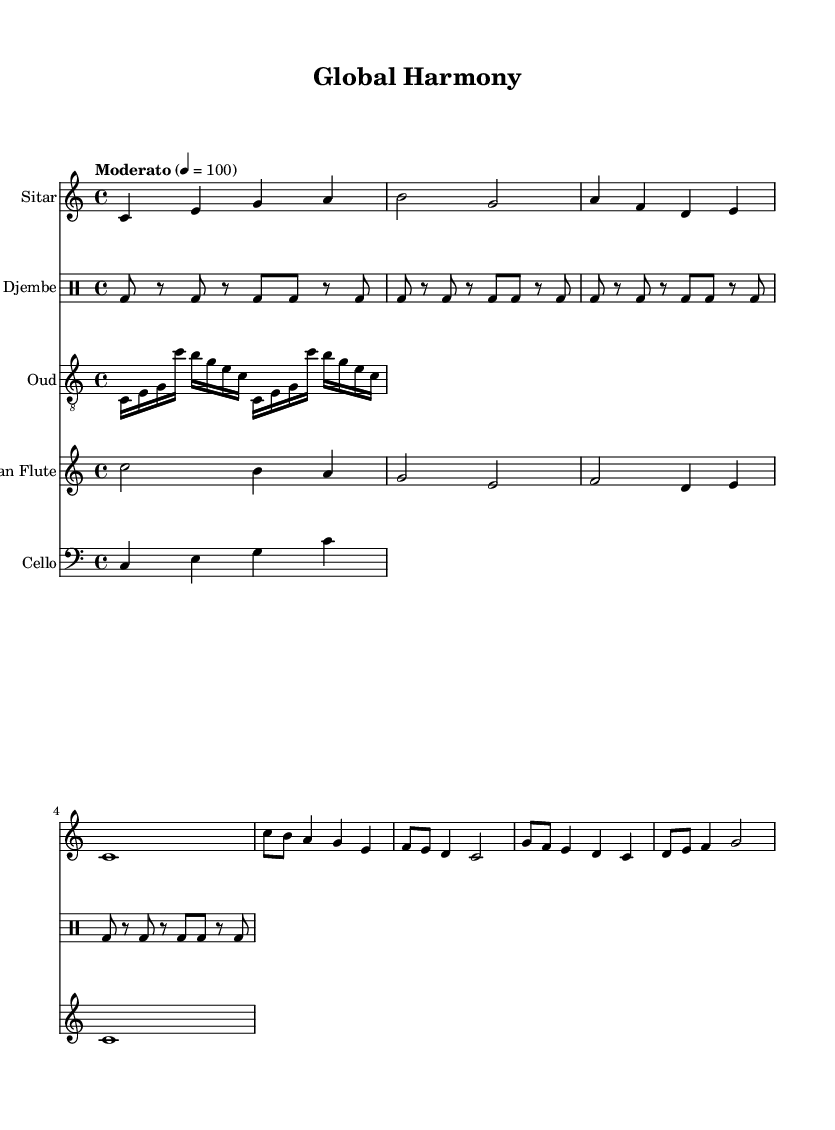What is the key signature of this music? The key signature is C major, which is indicated by the lack of sharps or flats placed on the staff at the beginning of the score.
Answer: C major What is the time signature of this music? The time signature is 4/4, which is shown at the beginning of the score where it indicates that there are four beats per measure and the quarter note gets one beat.
Answer: 4/4 What is the tempo marking for this piece? The tempo marking is "Moderato," which is given above the staff indicating the speed at which the music should be played, specifically at a moderate pace of 100 beats per minute.
Answer: Moderato Which instrument has the longest note value in the first measure? The instrument with the longest note value in the first measure is the sitar, which plays a whole note (c1) while other instruments have shorter note values.
Answer: Sitar How many times is the djembe's bass drum played in the first four measures? The bass drum is played 8 times in the first four measures. Each measure in the djembe part consists of 2 bass drum hits, repeated 4 times (2 hits x 4 measures).
Answer: 8 What unique instruments are featured in this fusion music? The unique instruments featured are the sitar, oud, djembe, Andean flute, and cello. Each instrument brings a different cultural perspective to the piece, reflecting the theme of global harmony.
Answer: Sitar, oud, djembe, Andean flute, cello What is the rhythmic pattern of the oud part? The rhythmic pattern in the oud part consists of continuous sixteenth notes for the first two measures, creating a flowing melodic line before moving into more structured rhythms.
Answer: Continuous sixteenth notes 